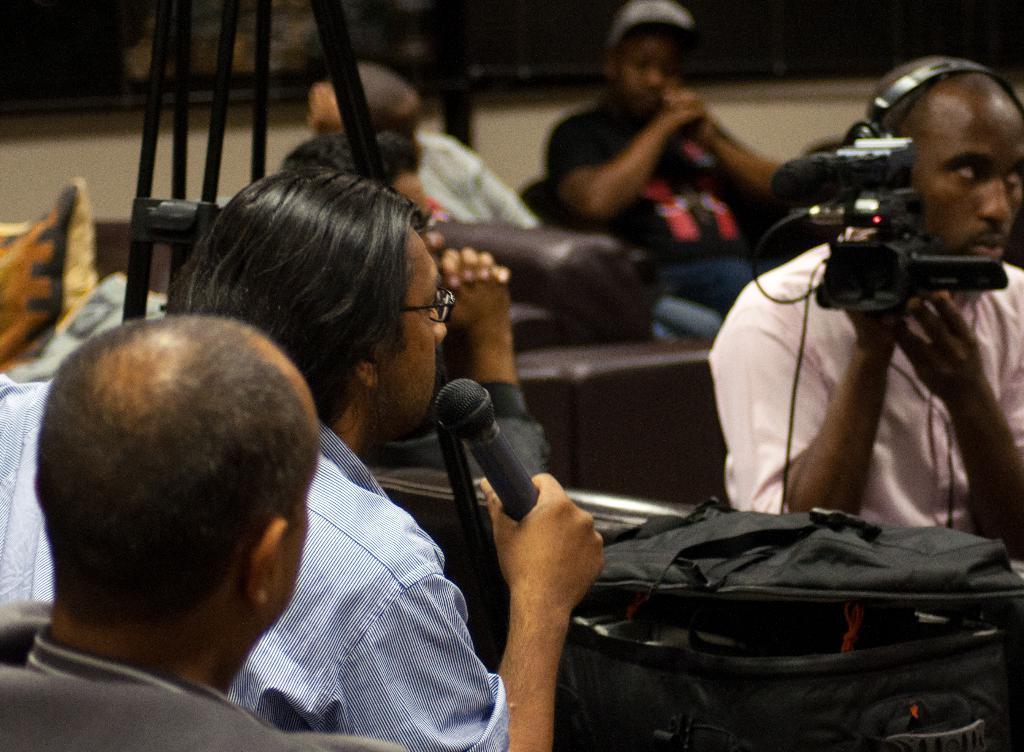Please provide a concise description of this image. As we can see in the image there are few people sitting on sofas. On the right side there is a man holding camera and this person is holding mic. 